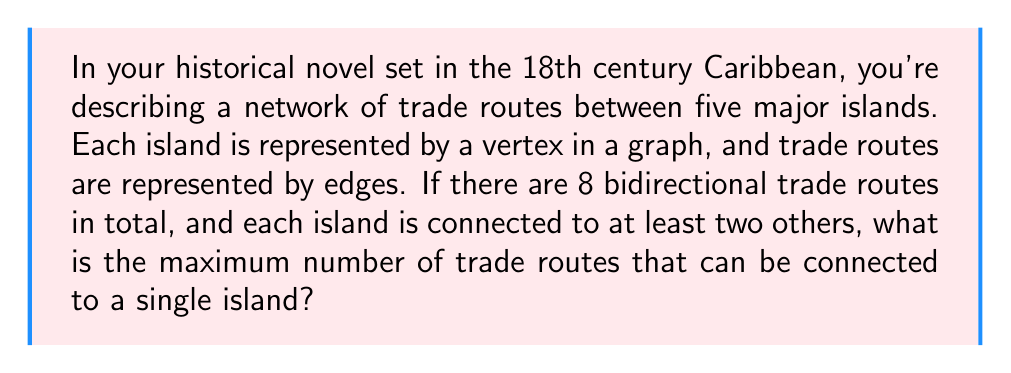Provide a solution to this math problem. Let's approach this step-by-step using graph theory:

1) We have a graph with 5 vertices (islands) and 8 edges (trade routes).

2) The question asks for the maximum degree of any vertex in this graph.

3) First, we need to ensure each vertex has a minimum degree of 2:
   $$5 \cdot 2 = 10$$ edges would be needed if each vertex had exactly 2 edges.

4) However, we only have 8 edges. This means some vertices must share edges to reduce the total.

5) The most efficient way to do this is to have one central vertex connected to all others, forming a star-like pattern.

6) In a graph with 5 vertices, the maximum possible degree for any vertex is 4, as it can connect to all other vertices.

7) Let's distribute the edges:
   - 4 edges for the central vertex
   - 1 edge each for the remaining 4 vertices (to connect to the central one)

8) This totals to: $$4 + 1 + 1 + 1 + 1 = 8$$ edges

9) This configuration satisfies all conditions: 8 total edges, each vertex has at least 2 connections, and we've maximized the degree of one vertex.

Therefore, the maximum number of trade routes that can be connected to a single island is 4.
Answer: 4 